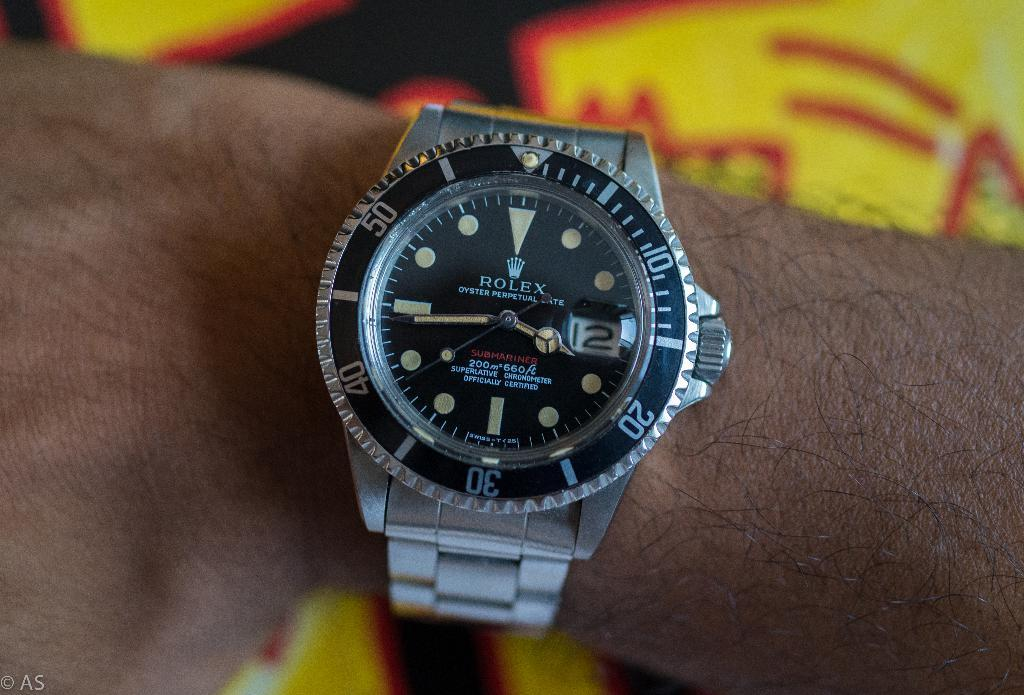<image>
Relay a brief, clear account of the picture shown. A person is wearing a silver Rolex watch on their wrist. 